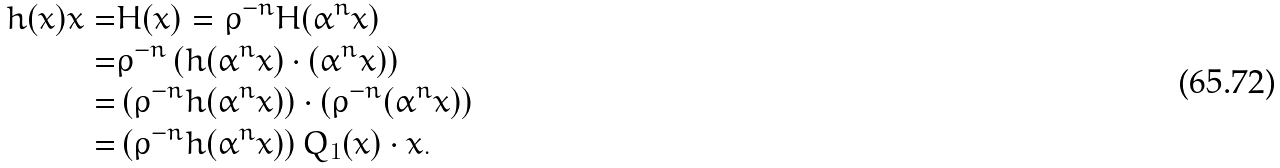<formula> <loc_0><loc_0><loc_500><loc_500>h ( x ) x = & H ( x ) = \rho ^ { - n } H ( \alpha ^ { n } x ) \\ = & \rho ^ { - n } \left ( h ( \alpha ^ { n } x ) \cdot ( \alpha ^ { n } x ) \right ) \\ = & \left ( \rho ^ { - n } h ( \alpha ^ { n } x ) \right ) \cdot \left ( \rho ^ { - n } ( \alpha ^ { n } x ) \right ) \\ = & \left ( \rho ^ { - n } h ( \alpha ^ { n } x ) \right ) Q _ { 1 } ( x ) \cdot x .</formula> 